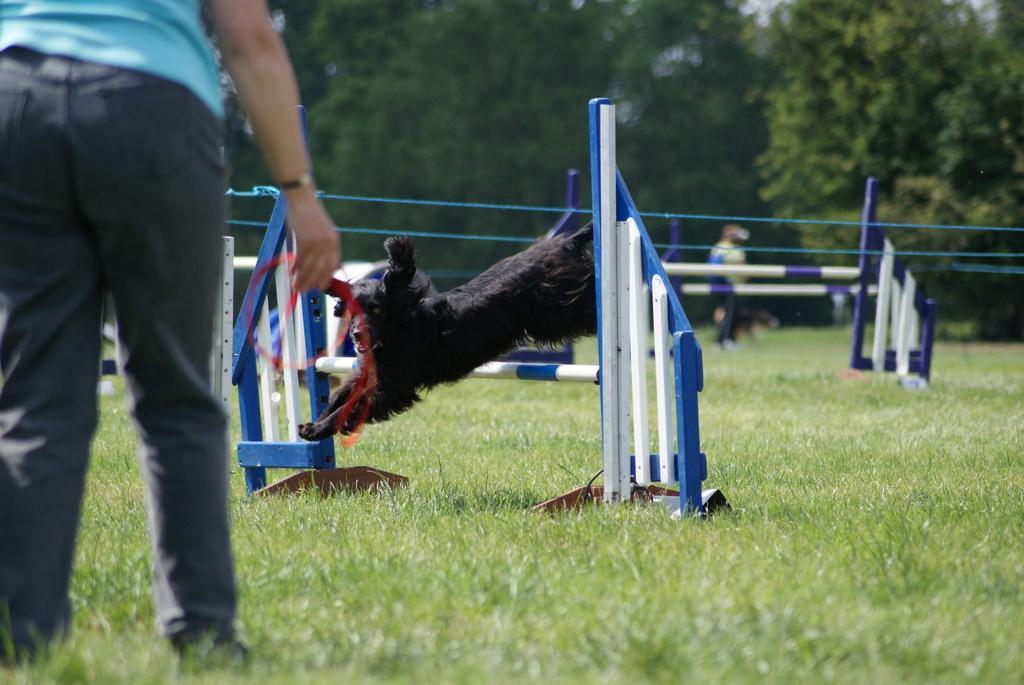Could you give a brief overview of what you see in this image? In this picture we can see a person on the left side, at the bottom there is grass, we can see a dog jumping, in the background there are some trees, we can see another person in the background. 